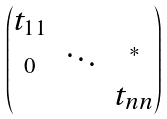<formula> <loc_0><loc_0><loc_500><loc_500>\begin{pmatrix} t _ { 1 1 } & \\ _ { 0 } & \ddots & ^ { * } \\ & & t _ { n n } \end{pmatrix}</formula> 